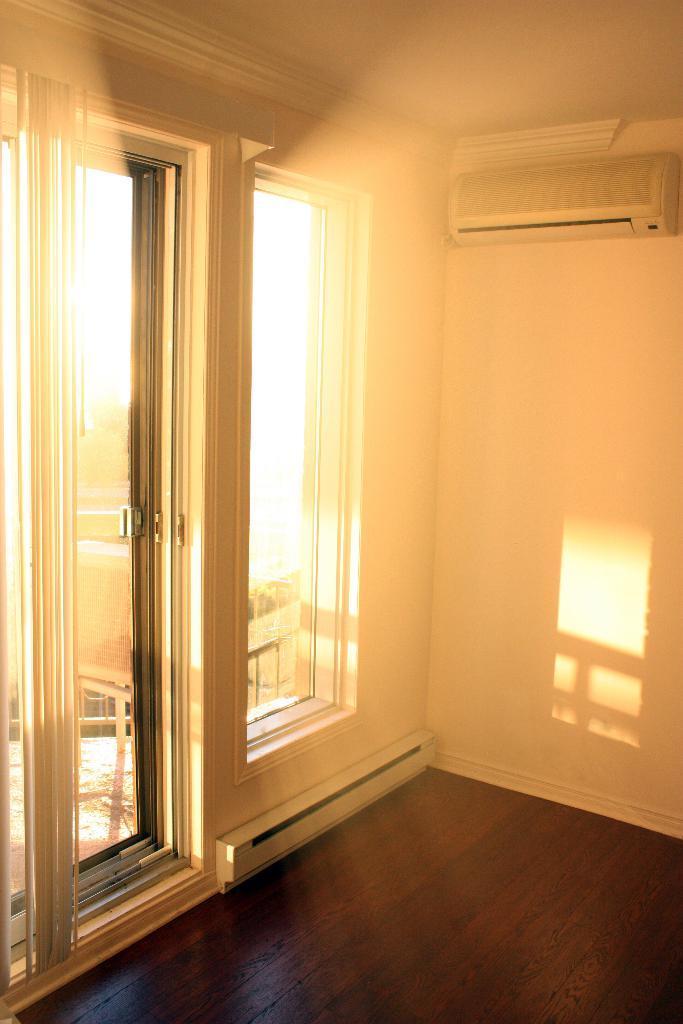Can you describe this image briefly? This is an inside view of a room. There is a wall with an AC. Also there is a window and door. 